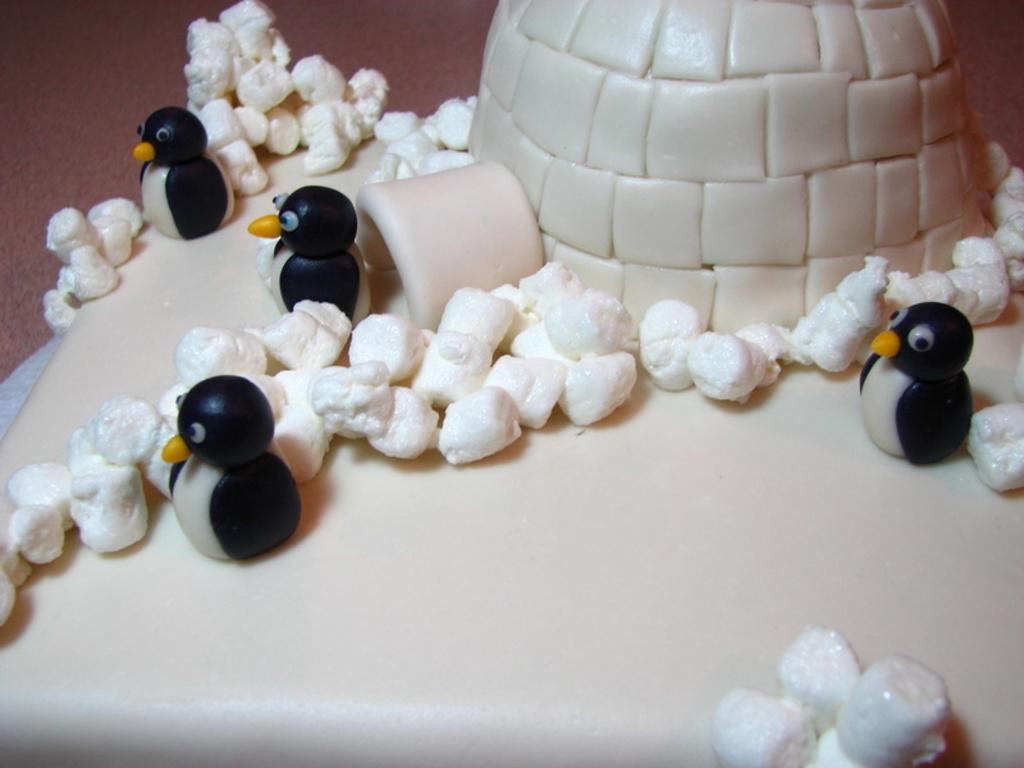In one or two sentences, can you explain what this image depicts? In this image there is a cake with penguins, marshmallows and igloo on it. 